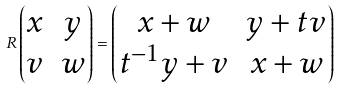Convert formula to latex. <formula><loc_0><loc_0><loc_500><loc_500>R \begin{pmatrix} x & y \\ v & w \end{pmatrix} = \begin{pmatrix} x + w & y + t v \\ t ^ { - 1 } y + v & x + w \end{pmatrix}</formula> 